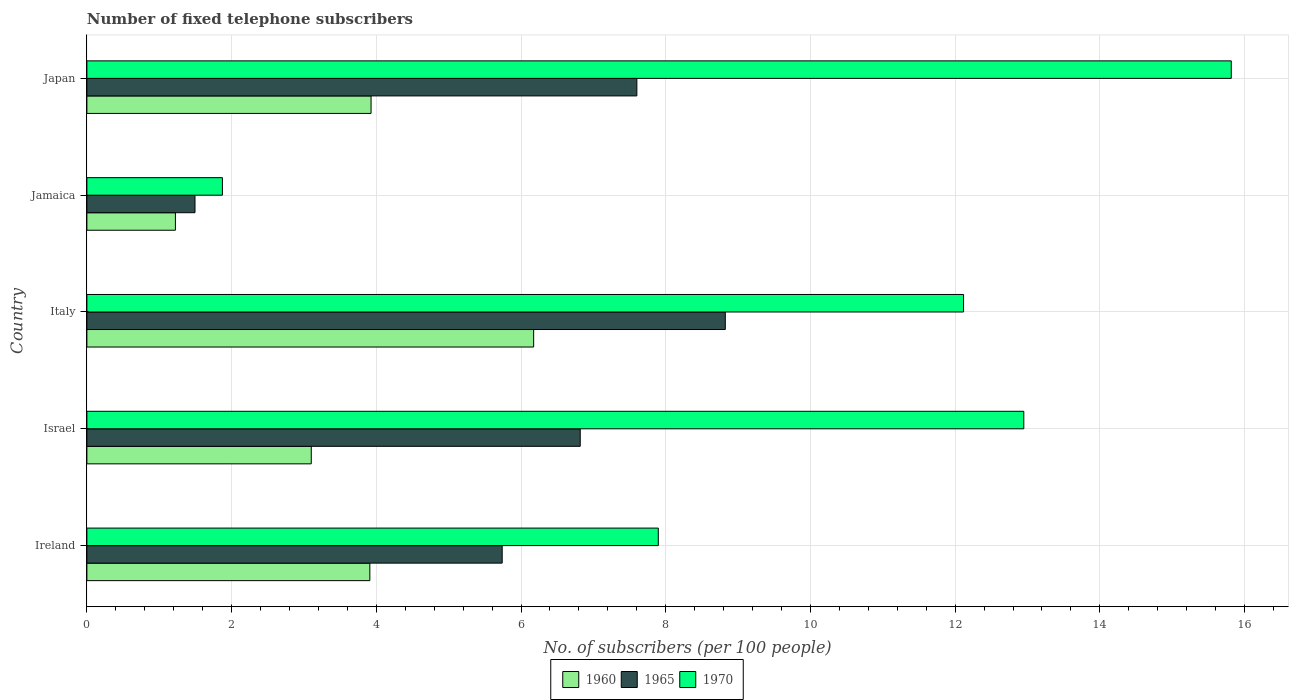How many groups of bars are there?
Offer a terse response. 5. Are the number of bars on each tick of the Y-axis equal?
Give a very brief answer. Yes. How many bars are there on the 5th tick from the bottom?
Your response must be concise. 3. What is the label of the 2nd group of bars from the top?
Provide a succinct answer. Jamaica. What is the number of fixed telephone subscribers in 1970 in Italy?
Your answer should be compact. 12.12. Across all countries, what is the maximum number of fixed telephone subscribers in 1960?
Give a very brief answer. 6.17. Across all countries, what is the minimum number of fixed telephone subscribers in 1965?
Offer a very short reply. 1.49. In which country was the number of fixed telephone subscribers in 1970 maximum?
Ensure brevity in your answer.  Japan. In which country was the number of fixed telephone subscribers in 1965 minimum?
Give a very brief answer. Jamaica. What is the total number of fixed telephone subscribers in 1960 in the graph?
Keep it short and to the point. 18.34. What is the difference between the number of fixed telephone subscribers in 1965 in Jamaica and that in Japan?
Provide a short and direct response. -6.11. What is the difference between the number of fixed telephone subscribers in 1970 in Italy and the number of fixed telephone subscribers in 1965 in Jamaica?
Keep it short and to the point. 10.62. What is the average number of fixed telephone subscribers in 1960 per country?
Your answer should be compact. 3.67. What is the difference between the number of fixed telephone subscribers in 1970 and number of fixed telephone subscribers in 1960 in Israel?
Your response must be concise. 9.85. What is the ratio of the number of fixed telephone subscribers in 1965 in Israel to that in Japan?
Keep it short and to the point. 0.9. Is the number of fixed telephone subscribers in 1970 in Israel less than that in Japan?
Provide a succinct answer. Yes. Is the difference between the number of fixed telephone subscribers in 1970 in Italy and Jamaica greater than the difference between the number of fixed telephone subscribers in 1960 in Italy and Jamaica?
Provide a short and direct response. Yes. What is the difference between the highest and the second highest number of fixed telephone subscribers in 1965?
Offer a terse response. 1.22. What is the difference between the highest and the lowest number of fixed telephone subscribers in 1960?
Make the answer very short. 4.95. What does the 2nd bar from the bottom in Israel represents?
Provide a succinct answer. 1965. Is it the case that in every country, the sum of the number of fixed telephone subscribers in 1960 and number of fixed telephone subscribers in 1970 is greater than the number of fixed telephone subscribers in 1965?
Offer a very short reply. Yes. How many countries are there in the graph?
Ensure brevity in your answer.  5. Are the values on the major ticks of X-axis written in scientific E-notation?
Your answer should be very brief. No. Does the graph contain any zero values?
Your response must be concise. No. Does the graph contain grids?
Ensure brevity in your answer.  Yes. Where does the legend appear in the graph?
Keep it short and to the point. Bottom center. How many legend labels are there?
Provide a short and direct response. 3. What is the title of the graph?
Offer a terse response. Number of fixed telephone subscribers. Does "1990" appear as one of the legend labels in the graph?
Ensure brevity in your answer.  No. What is the label or title of the X-axis?
Provide a short and direct response. No. of subscribers (per 100 people). What is the No. of subscribers (per 100 people) of 1960 in Ireland?
Ensure brevity in your answer.  3.91. What is the No. of subscribers (per 100 people) in 1965 in Ireland?
Provide a short and direct response. 5.74. What is the No. of subscribers (per 100 people) in 1970 in Ireland?
Keep it short and to the point. 7.9. What is the No. of subscribers (per 100 people) of 1960 in Israel?
Offer a terse response. 3.1. What is the No. of subscribers (per 100 people) of 1965 in Israel?
Your answer should be very brief. 6.82. What is the No. of subscribers (per 100 people) of 1970 in Israel?
Make the answer very short. 12.95. What is the No. of subscribers (per 100 people) of 1960 in Italy?
Ensure brevity in your answer.  6.17. What is the No. of subscribers (per 100 people) of 1965 in Italy?
Your answer should be very brief. 8.82. What is the No. of subscribers (per 100 people) in 1970 in Italy?
Offer a very short reply. 12.12. What is the No. of subscribers (per 100 people) of 1960 in Jamaica?
Provide a short and direct response. 1.22. What is the No. of subscribers (per 100 people) of 1965 in Jamaica?
Your answer should be very brief. 1.49. What is the No. of subscribers (per 100 people) in 1970 in Jamaica?
Keep it short and to the point. 1.87. What is the No. of subscribers (per 100 people) in 1960 in Japan?
Provide a short and direct response. 3.93. What is the No. of subscribers (per 100 people) of 1965 in Japan?
Give a very brief answer. 7.6. What is the No. of subscribers (per 100 people) in 1970 in Japan?
Offer a very short reply. 15.82. Across all countries, what is the maximum No. of subscribers (per 100 people) of 1960?
Your answer should be compact. 6.17. Across all countries, what is the maximum No. of subscribers (per 100 people) in 1965?
Make the answer very short. 8.82. Across all countries, what is the maximum No. of subscribers (per 100 people) of 1970?
Your answer should be compact. 15.82. Across all countries, what is the minimum No. of subscribers (per 100 people) of 1960?
Offer a very short reply. 1.22. Across all countries, what is the minimum No. of subscribers (per 100 people) in 1965?
Offer a terse response. 1.49. Across all countries, what is the minimum No. of subscribers (per 100 people) of 1970?
Make the answer very short. 1.87. What is the total No. of subscribers (per 100 people) in 1960 in the graph?
Make the answer very short. 18.34. What is the total No. of subscribers (per 100 people) of 1965 in the graph?
Give a very brief answer. 30.48. What is the total No. of subscribers (per 100 people) of 1970 in the graph?
Provide a succinct answer. 50.65. What is the difference between the No. of subscribers (per 100 people) of 1960 in Ireland and that in Israel?
Offer a terse response. 0.81. What is the difference between the No. of subscribers (per 100 people) in 1965 in Ireland and that in Israel?
Keep it short and to the point. -1.08. What is the difference between the No. of subscribers (per 100 people) of 1970 in Ireland and that in Israel?
Offer a terse response. -5.05. What is the difference between the No. of subscribers (per 100 people) of 1960 in Ireland and that in Italy?
Ensure brevity in your answer.  -2.26. What is the difference between the No. of subscribers (per 100 people) of 1965 in Ireland and that in Italy?
Offer a terse response. -3.08. What is the difference between the No. of subscribers (per 100 people) in 1970 in Ireland and that in Italy?
Offer a terse response. -4.22. What is the difference between the No. of subscribers (per 100 people) of 1960 in Ireland and that in Jamaica?
Provide a short and direct response. 2.69. What is the difference between the No. of subscribers (per 100 people) in 1965 in Ireland and that in Jamaica?
Give a very brief answer. 4.25. What is the difference between the No. of subscribers (per 100 people) in 1970 in Ireland and that in Jamaica?
Your answer should be very brief. 6.02. What is the difference between the No. of subscribers (per 100 people) of 1960 in Ireland and that in Japan?
Ensure brevity in your answer.  -0.02. What is the difference between the No. of subscribers (per 100 people) in 1965 in Ireland and that in Japan?
Offer a terse response. -1.86. What is the difference between the No. of subscribers (per 100 people) in 1970 in Ireland and that in Japan?
Keep it short and to the point. -7.92. What is the difference between the No. of subscribers (per 100 people) of 1960 in Israel and that in Italy?
Your response must be concise. -3.07. What is the difference between the No. of subscribers (per 100 people) of 1965 in Israel and that in Italy?
Offer a terse response. -2. What is the difference between the No. of subscribers (per 100 people) of 1970 in Israel and that in Italy?
Ensure brevity in your answer.  0.83. What is the difference between the No. of subscribers (per 100 people) of 1960 in Israel and that in Jamaica?
Make the answer very short. 1.88. What is the difference between the No. of subscribers (per 100 people) of 1965 in Israel and that in Jamaica?
Your response must be concise. 5.32. What is the difference between the No. of subscribers (per 100 people) of 1970 in Israel and that in Jamaica?
Give a very brief answer. 11.08. What is the difference between the No. of subscribers (per 100 people) in 1960 in Israel and that in Japan?
Ensure brevity in your answer.  -0.83. What is the difference between the No. of subscribers (per 100 people) of 1965 in Israel and that in Japan?
Give a very brief answer. -0.78. What is the difference between the No. of subscribers (per 100 people) of 1970 in Israel and that in Japan?
Your answer should be compact. -2.87. What is the difference between the No. of subscribers (per 100 people) in 1960 in Italy and that in Jamaica?
Provide a succinct answer. 4.95. What is the difference between the No. of subscribers (per 100 people) in 1965 in Italy and that in Jamaica?
Give a very brief answer. 7.33. What is the difference between the No. of subscribers (per 100 people) of 1970 in Italy and that in Jamaica?
Your answer should be very brief. 10.24. What is the difference between the No. of subscribers (per 100 people) in 1960 in Italy and that in Japan?
Your answer should be very brief. 2.25. What is the difference between the No. of subscribers (per 100 people) of 1965 in Italy and that in Japan?
Your response must be concise. 1.22. What is the difference between the No. of subscribers (per 100 people) of 1970 in Italy and that in Japan?
Offer a very short reply. -3.7. What is the difference between the No. of subscribers (per 100 people) in 1960 in Jamaica and that in Japan?
Make the answer very short. -2.7. What is the difference between the No. of subscribers (per 100 people) of 1965 in Jamaica and that in Japan?
Your response must be concise. -6.11. What is the difference between the No. of subscribers (per 100 people) in 1970 in Jamaica and that in Japan?
Offer a terse response. -13.94. What is the difference between the No. of subscribers (per 100 people) of 1960 in Ireland and the No. of subscribers (per 100 people) of 1965 in Israel?
Keep it short and to the point. -2.91. What is the difference between the No. of subscribers (per 100 people) in 1960 in Ireland and the No. of subscribers (per 100 people) in 1970 in Israel?
Provide a short and direct response. -9.04. What is the difference between the No. of subscribers (per 100 people) of 1965 in Ireland and the No. of subscribers (per 100 people) of 1970 in Israel?
Offer a very short reply. -7.21. What is the difference between the No. of subscribers (per 100 people) in 1960 in Ireland and the No. of subscribers (per 100 people) in 1965 in Italy?
Provide a succinct answer. -4.91. What is the difference between the No. of subscribers (per 100 people) of 1960 in Ireland and the No. of subscribers (per 100 people) of 1970 in Italy?
Make the answer very short. -8.21. What is the difference between the No. of subscribers (per 100 people) in 1965 in Ireland and the No. of subscribers (per 100 people) in 1970 in Italy?
Offer a terse response. -6.38. What is the difference between the No. of subscribers (per 100 people) in 1960 in Ireland and the No. of subscribers (per 100 people) in 1965 in Jamaica?
Give a very brief answer. 2.42. What is the difference between the No. of subscribers (per 100 people) in 1960 in Ireland and the No. of subscribers (per 100 people) in 1970 in Jamaica?
Make the answer very short. 2.04. What is the difference between the No. of subscribers (per 100 people) of 1965 in Ireland and the No. of subscribers (per 100 people) of 1970 in Jamaica?
Provide a short and direct response. 3.87. What is the difference between the No. of subscribers (per 100 people) in 1960 in Ireland and the No. of subscribers (per 100 people) in 1965 in Japan?
Ensure brevity in your answer.  -3.69. What is the difference between the No. of subscribers (per 100 people) in 1960 in Ireland and the No. of subscribers (per 100 people) in 1970 in Japan?
Provide a short and direct response. -11.91. What is the difference between the No. of subscribers (per 100 people) in 1965 in Ireland and the No. of subscribers (per 100 people) in 1970 in Japan?
Provide a short and direct response. -10.08. What is the difference between the No. of subscribers (per 100 people) of 1960 in Israel and the No. of subscribers (per 100 people) of 1965 in Italy?
Your answer should be very brief. -5.72. What is the difference between the No. of subscribers (per 100 people) in 1960 in Israel and the No. of subscribers (per 100 people) in 1970 in Italy?
Offer a terse response. -9.02. What is the difference between the No. of subscribers (per 100 people) of 1965 in Israel and the No. of subscribers (per 100 people) of 1970 in Italy?
Keep it short and to the point. -5.3. What is the difference between the No. of subscribers (per 100 people) in 1960 in Israel and the No. of subscribers (per 100 people) in 1965 in Jamaica?
Provide a succinct answer. 1.61. What is the difference between the No. of subscribers (per 100 people) in 1960 in Israel and the No. of subscribers (per 100 people) in 1970 in Jamaica?
Keep it short and to the point. 1.23. What is the difference between the No. of subscribers (per 100 people) of 1965 in Israel and the No. of subscribers (per 100 people) of 1970 in Jamaica?
Your response must be concise. 4.95. What is the difference between the No. of subscribers (per 100 people) in 1960 in Israel and the No. of subscribers (per 100 people) in 1965 in Japan?
Give a very brief answer. -4.5. What is the difference between the No. of subscribers (per 100 people) in 1960 in Israel and the No. of subscribers (per 100 people) in 1970 in Japan?
Offer a very short reply. -12.72. What is the difference between the No. of subscribers (per 100 people) of 1965 in Israel and the No. of subscribers (per 100 people) of 1970 in Japan?
Your answer should be compact. -9. What is the difference between the No. of subscribers (per 100 people) of 1960 in Italy and the No. of subscribers (per 100 people) of 1965 in Jamaica?
Your answer should be compact. 4.68. What is the difference between the No. of subscribers (per 100 people) in 1960 in Italy and the No. of subscribers (per 100 people) in 1970 in Jamaica?
Offer a very short reply. 4.3. What is the difference between the No. of subscribers (per 100 people) of 1965 in Italy and the No. of subscribers (per 100 people) of 1970 in Jamaica?
Offer a terse response. 6.95. What is the difference between the No. of subscribers (per 100 people) in 1960 in Italy and the No. of subscribers (per 100 people) in 1965 in Japan?
Provide a succinct answer. -1.43. What is the difference between the No. of subscribers (per 100 people) of 1960 in Italy and the No. of subscribers (per 100 people) of 1970 in Japan?
Offer a terse response. -9.64. What is the difference between the No. of subscribers (per 100 people) in 1965 in Italy and the No. of subscribers (per 100 people) in 1970 in Japan?
Your answer should be very brief. -6.99. What is the difference between the No. of subscribers (per 100 people) of 1960 in Jamaica and the No. of subscribers (per 100 people) of 1965 in Japan?
Your answer should be very brief. -6.38. What is the difference between the No. of subscribers (per 100 people) in 1960 in Jamaica and the No. of subscribers (per 100 people) in 1970 in Japan?
Your answer should be very brief. -14.59. What is the difference between the No. of subscribers (per 100 people) of 1965 in Jamaica and the No. of subscribers (per 100 people) of 1970 in Japan?
Give a very brief answer. -14.32. What is the average No. of subscribers (per 100 people) in 1960 per country?
Ensure brevity in your answer.  3.67. What is the average No. of subscribers (per 100 people) of 1965 per country?
Your response must be concise. 6.1. What is the average No. of subscribers (per 100 people) in 1970 per country?
Provide a short and direct response. 10.13. What is the difference between the No. of subscribers (per 100 people) in 1960 and No. of subscribers (per 100 people) in 1965 in Ireland?
Provide a short and direct response. -1.83. What is the difference between the No. of subscribers (per 100 people) in 1960 and No. of subscribers (per 100 people) in 1970 in Ireland?
Give a very brief answer. -3.99. What is the difference between the No. of subscribers (per 100 people) of 1965 and No. of subscribers (per 100 people) of 1970 in Ireland?
Offer a very short reply. -2.16. What is the difference between the No. of subscribers (per 100 people) of 1960 and No. of subscribers (per 100 people) of 1965 in Israel?
Keep it short and to the point. -3.72. What is the difference between the No. of subscribers (per 100 people) in 1960 and No. of subscribers (per 100 people) in 1970 in Israel?
Provide a succinct answer. -9.85. What is the difference between the No. of subscribers (per 100 people) of 1965 and No. of subscribers (per 100 people) of 1970 in Israel?
Provide a short and direct response. -6.13. What is the difference between the No. of subscribers (per 100 people) in 1960 and No. of subscribers (per 100 people) in 1965 in Italy?
Provide a short and direct response. -2.65. What is the difference between the No. of subscribers (per 100 people) of 1960 and No. of subscribers (per 100 people) of 1970 in Italy?
Offer a very short reply. -5.94. What is the difference between the No. of subscribers (per 100 people) in 1965 and No. of subscribers (per 100 people) in 1970 in Italy?
Provide a short and direct response. -3.29. What is the difference between the No. of subscribers (per 100 people) in 1960 and No. of subscribers (per 100 people) in 1965 in Jamaica?
Your answer should be compact. -0.27. What is the difference between the No. of subscribers (per 100 people) in 1960 and No. of subscribers (per 100 people) in 1970 in Jamaica?
Your response must be concise. -0.65. What is the difference between the No. of subscribers (per 100 people) in 1965 and No. of subscribers (per 100 people) in 1970 in Jamaica?
Provide a short and direct response. -0.38. What is the difference between the No. of subscribers (per 100 people) in 1960 and No. of subscribers (per 100 people) in 1965 in Japan?
Offer a very short reply. -3.67. What is the difference between the No. of subscribers (per 100 people) of 1960 and No. of subscribers (per 100 people) of 1970 in Japan?
Give a very brief answer. -11.89. What is the difference between the No. of subscribers (per 100 people) in 1965 and No. of subscribers (per 100 people) in 1970 in Japan?
Give a very brief answer. -8.22. What is the ratio of the No. of subscribers (per 100 people) in 1960 in Ireland to that in Israel?
Provide a succinct answer. 1.26. What is the ratio of the No. of subscribers (per 100 people) of 1965 in Ireland to that in Israel?
Your answer should be very brief. 0.84. What is the ratio of the No. of subscribers (per 100 people) of 1970 in Ireland to that in Israel?
Give a very brief answer. 0.61. What is the ratio of the No. of subscribers (per 100 people) of 1960 in Ireland to that in Italy?
Ensure brevity in your answer.  0.63. What is the ratio of the No. of subscribers (per 100 people) of 1965 in Ireland to that in Italy?
Keep it short and to the point. 0.65. What is the ratio of the No. of subscribers (per 100 people) of 1970 in Ireland to that in Italy?
Your answer should be very brief. 0.65. What is the ratio of the No. of subscribers (per 100 people) in 1960 in Ireland to that in Jamaica?
Offer a terse response. 3.2. What is the ratio of the No. of subscribers (per 100 people) in 1965 in Ireland to that in Jamaica?
Provide a short and direct response. 3.84. What is the ratio of the No. of subscribers (per 100 people) of 1970 in Ireland to that in Jamaica?
Your answer should be compact. 4.22. What is the ratio of the No. of subscribers (per 100 people) in 1960 in Ireland to that in Japan?
Your answer should be compact. 1. What is the ratio of the No. of subscribers (per 100 people) in 1965 in Ireland to that in Japan?
Ensure brevity in your answer.  0.76. What is the ratio of the No. of subscribers (per 100 people) in 1970 in Ireland to that in Japan?
Provide a short and direct response. 0.5. What is the ratio of the No. of subscribers (per 100 people) in 1960 in Israel to that in Italy?
Offer a terse response. 0.5. What is the ratio of the No. of subscribers (per 100 people) of 1965 in Israel to that in Italy?
Give a very brief answer. 0.77. What is the ratio of the No. of subscribers (per 100 people) of 1970 in Israel to that in Italy?
Give a very brief answer. 1.07. What is the ratio of the No. of subscribers (per 100 people) in 1960 in Israel to that in Jamaica?
Ensure brevity in your answer.  2.53. What is the ratio of the No. of subscribers (per 100 people) of 1965 in Israel to that in Jamaica?
Your response must be concise. 4.56. What is the ratio of the No. of subscribers (per 100 people) in 1970 in Israel to that in Jamaica?
Make the answer very short. 6.91. What is the ratio of the No. of subscribers (per 100 people) in 1960 in Israel to that in Japan?
Your response must be concise. 0.79. What is the ratio of the No. of subscribers (per 100 people) in 1965 in Israel to that in Japan?
Your answer should be compact. 0.9. What is the ratio of the No. of subscribers (per 100 people) in 1970 in Israel to that in Japan?
Offer a terse response. 0.82. What is the ratio of the No. of subscribers (per 100 people) of 1960 in Italy to that in Jamaica?
Your response must be concise. 5.05. What is the ratio of the No. of subscribers (per 100 people) in 1965 in Italy to that in Jamaica?
Ensure brevity in your answer.  5.91. What is the ratio of the No. of subscribers (per 100 people) of 1970 in Italy to that in Jamaica?
Ensure brevity in your answer.  6.47. What is the ratio of the No. of subscribers (per 100 people) of 1960 in Italy to that in Japan?
Your answer should be very brief. 1.57. What is the ratio of the No. of subscribers (per 100 people) of 1965 in Italy to that in Japan?
Provide a succinct answer. 1.16. What is the ratio of the No. of subscribers (per 100 people) of 1970 in Italy to that in Japan?
Keep it short and to the point. 0.77. What is the ratio of the No. of subscribers (per 100 people) in 1960 in Jamaica to that in Japan?
Make the answer very short. 0.31. What is the ratio of the No. of subscribers (per 100 people) in 1965 in Jamaica to that in Japan?
Offer a very short reply. 0.2. What is the ratio of the No. of subscribers (per 100 people) in 1970 in Jamaica to that in Japan?
Keep it short and to the point. 0.12. What is the difference between the highest and the second highest No. of subscribers (per 100 people) in 1960?
Offer a very short reply. 2.25. What is the difference between the highest and the second highest No. of subscribers (per 100 people) of 1965?
Keep it short and to the point. 1.22. What is the difference between the highest and the second highest No. of subscribers (per 100 people) in 1970?
Give a very brief answer. 2.87. What is the difference between the highest and the lowest No. of subscribers (per 100 people) of 1960?
Provide a succinct answer. 4.95. What is the difference between the highest and the lowest No. of subscribers (per 100 people) of 1965?
Ensure brevity in your answer.  7.33. What is the difference between the highest and the lowest No. of subscribers (per 100 people) in 1970?
Your answer should be compact. 13.94. 